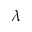Convert formula to latex. <formula><loc_0><loc_0><loc_500><loc_500>\lambda</formula> 